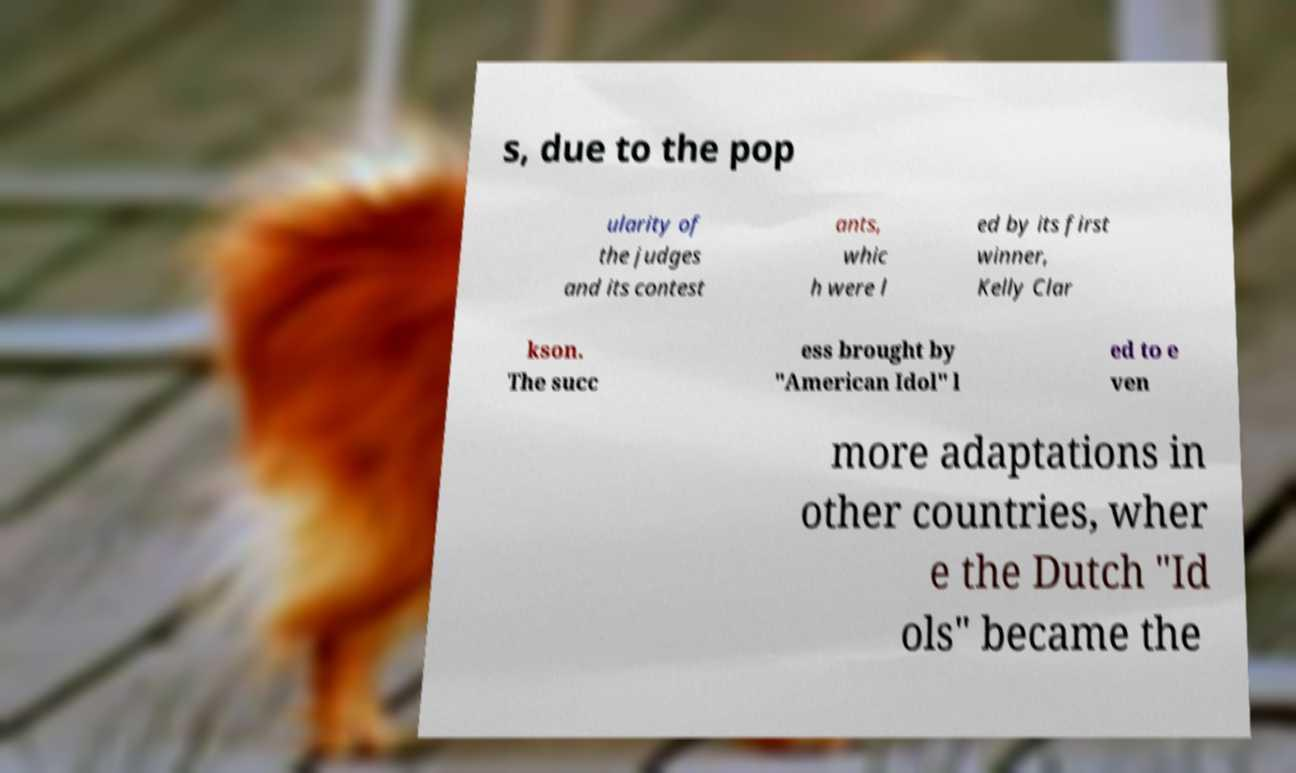There's text embedded in this image that I need extracted. Can you transcribe it verbatim? s, due to the pop ularity of the judges and its contest ants, whic h were l ed by its first winner, Kelly Clar kson. The succ ess brought by "American Idol" l ed to e ven more adaptations in other countries, wher e the Dutch "Id ols" became the 